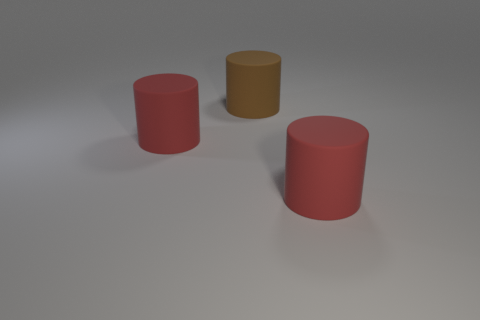Subtract all red cylinders. How many were subtracted if there are1red cylinders left? 1 Add 2 small red balls. How many objects exist? 5 Add 1 red objects. How many red objects are left? 3 Add 1 red rubber blocks. How many red rubber blocks exist? 1 Subtract 0 purple spheres. How many objects are left? 3 Subtract all matte things. Subtract all small brown shiny cubes. How many objects are left? 0 